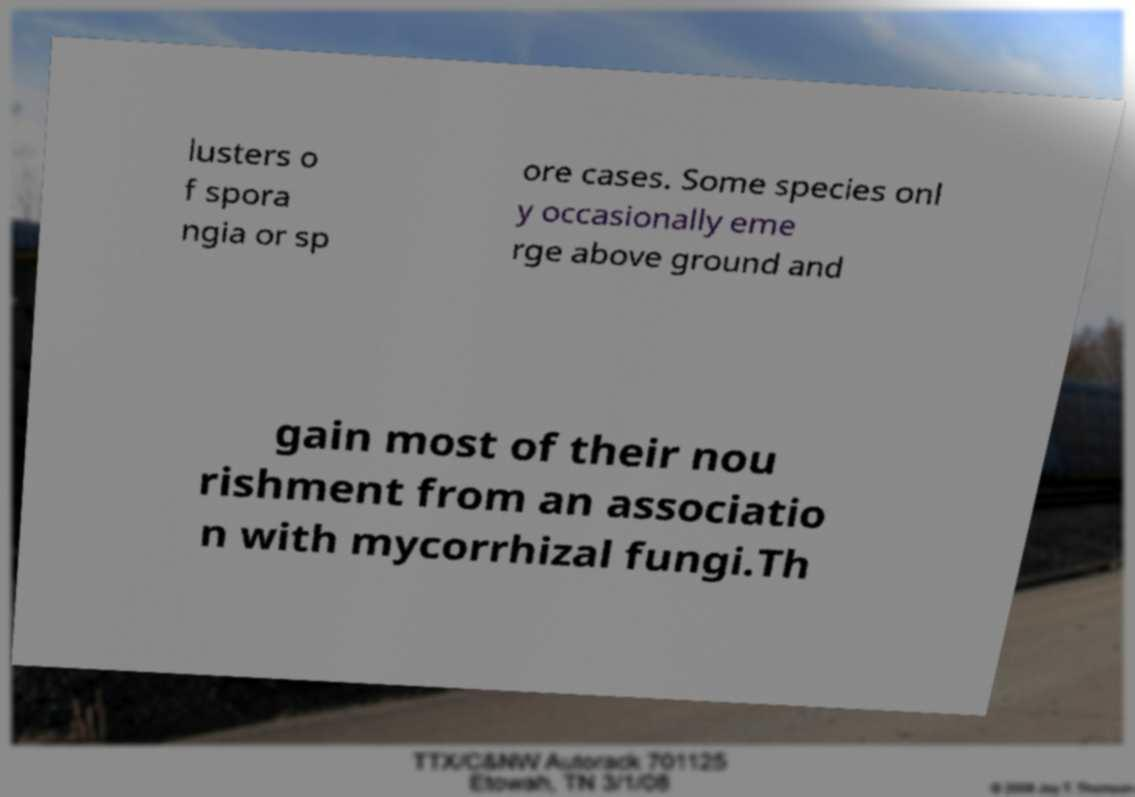What messages or text are displayed in this image? I need them in a readable, typed format. lusters o f spora ngia or sp ore cases. Some species onl y occasionally eme rge above ground and gain most of their nou rishment from an associatio n with mycorrhizal fungi.Th 